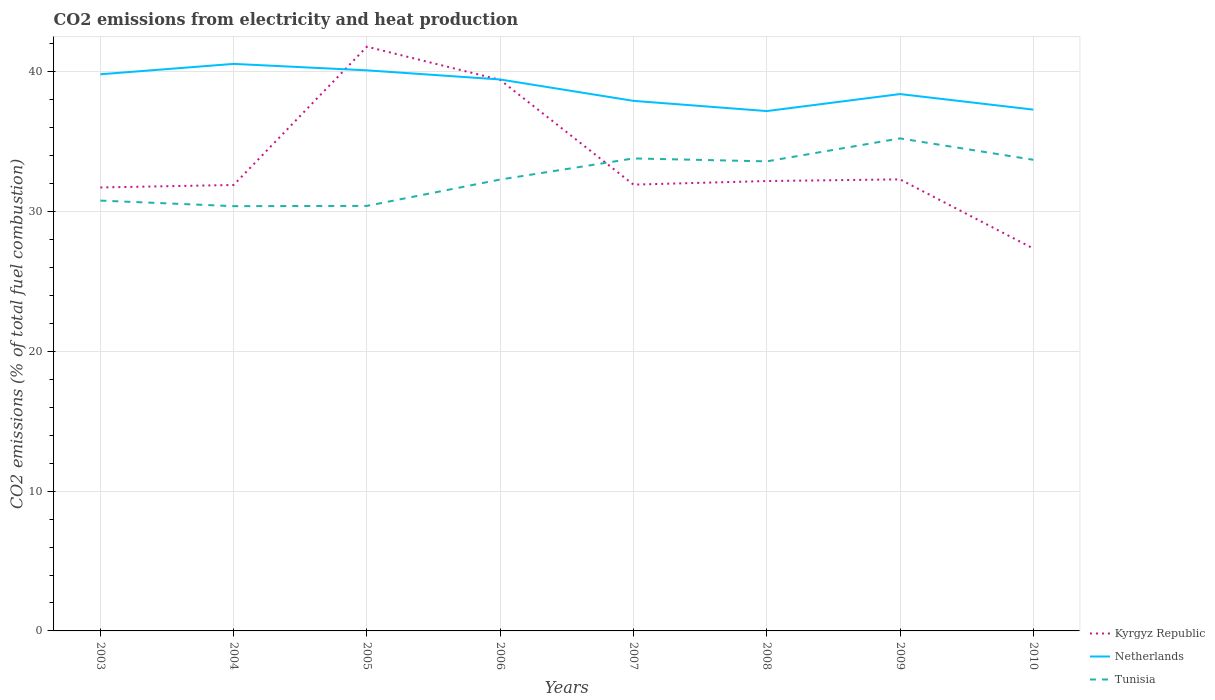Across all years, what is the maximum amount of CO2 emitted in Tunisia?
Your answer should be compact. 30.39. What is the total amount of CO2 emitted in Kyrgyz Republic in the graph?
Your answer should be compact. -0.46. What is the difference between the highest and the second highest amount of CO2 emitted in Netherlands?
Ensure brevity in your answer.  3.38. How many lines are there?
Your answer should be very brief. 3. How many years are there in the graph?
Ensure brevity in your answer.  8. What is the difference between two consecutive major ticks on the Y-axis?
Your answer should be compact. 10. Are the values on the major ticks of Y-axis written in scientific E-notation?
Provide a succinct answer. No. Does the graph contain any zero values?
Offer a terse response. No. Where does the legend appear in the graph?
Keep it short and to the point. Bottom right. How many legend labels are there?
Keep it short and to the point. 3. What is the title of the graph?
Provide a succinct answer. CO2 emissions from electricity and heat production. What is the label or title of the Y-axis?
Your answer should be compact. CO2 emissions (% of total fuel combustion). What is the CO2 emissions (% of total fuel combustion) in Kyrgyz Republic in 2003?
Make the answer very short. 31.73. What is the CO2 emissions (% of total fuel combustion) of Netherlands in 2003?
Provide a short and direct response. 39.83. What is the CO2 emissions (% of total fuel combustion) in Tunisia in 2003?
Provide a short and direct response. 30.79. What is the CO2 emissions (% of total fuel combustion) of Kyrgyz Republic in 2004?
Your response must be concise. 31.91. What is the CO2 emissions (% of total fuel combustion) in Netherlands in 2004?
Ensure brevity in your answer.  40.57. What is the CO2 emissions (% of total fuel combustion) in Tunisia in 2004?
Offer a very short reply. 30.39. What is the CO2 emissions (% of total fuel combustion) of Kyrgyz Republic in 2005?
Ensure brevity in your answer.  41.8. What is the CO2 emissions (% of total fuel combustion) of Netherlands in 2005?
Offer a terse response. 40.11. What is the CO2 emissions (% of total fuel combustion) of Tunisia in 2005?
Ensure brevity in your answer.  30.41. What is the CO2 emissions (% of total fuel combustion) in Kyrgyz Republic in 2006?
Offer a very short reply. 39.43. What is the CO2 emissions (% of total fuel combustion) of Netherlands in 2006?
Give a very brief answer. 39.45. What is the CO2 emissions (% of total fuel combustion) in Tunisia in 2006?
Provide a succinct answer. 32.3. What is the CO2 emissions (% of total fuel combustion) of Kyrgyz Republic in 2007?
Provide a short and direct response. 31.93. What is the CO2 emissions (% of total fuel combustion) in Netherlands in 2007?
Provide a short and direct response. 37.93. What is the CO2 emissions (% of total fuel combustion) of Tunisia in 2007?
Offer a terse response. 33.81. What is the CO2 emissions (% of total fuel combustion) in Kyrgyz Republic in 2008?
Provide a succinct answer. 32.19. What is the CO2 emissions (% of total fuel combustion) of Netherlands in 2008?
Ensure brevity in your answer.  37.2. What is the CO2 emissions (% of total fuel combustion) of Tunisia in 2008?
Provide a succinct answer. 33.6. What is the CO2 emissions (% of total fuel combustion) of Kyrgyz Republic in 2009?
Give a very brief answer. 32.31. What is the CO2 emissions (% of total fuel combustion) of Netherlands in 2009?
Your answer should be compact. 38.41. What is the CO2 emissions (% of total fuel combustion) in Tunisia in 2009?
Provide a succinct answer. 35.24. What is the CO2 emissions (% of total fuel combustion) in Kyrgyz Republic in 2010?
Your answer should be very brief. 27.36. What is the CO2 emissions (% of total fuel combustion) in Netherlands in 2010?
Your answer should be compact. 37.3. What is the CO2 emissions (% of total fuel combustion) of Tunisia in 2010?
Your answer should be compact. 33.71. Across all years, what is the maximum CO2 emissions (% of total fuel combustion) of Kyrgyz Republic?
Provide a succinct answer. 41.8. Across all years, what is the maximum CO2 emissions (% of total fuel combustion) of Netherlands?
Offer a terse response. 40.57. Across all years, what is the maximum CO2 emissions (% of total fuel combustion) in Tunisia?
Give a very brief answer. 35.24. Across all years, what is the minimum CO2 emissions (% of total fuel combustion) of Kyrgyz Republic?
Provide a short and direct response. 27.36. Across all years, what is the minimum CO2 emissions (% of total fuel combustion) in Netherlands?
Your response must be concise. 37.2. Across all years, what is the minimum CO2 emissions (% of total fuel combustion) of Tunisia?
Provide a short and direct response. 30.39. What is the total CO2 emissions (% of total fuel combustion) in Kyrgyz Republic in the graph?
Give a very brief answer. 268.66. What is the total CO2 emissions (% of total fuel combustion) in Netherlands in the graph?
Your answer should be compact. 310.79. What is the total CO2 emissions (% of total fuel combustion) in Tunisia in the graph?
Offer a terse response. 260.24. What is the difference between the CO2 emissions (% of total fuel combustion) in Kyrgyz Republic in 2003 and that in 2004?
Ensure brevity in your answer.  -0.18. What is the difference between the CO2 emissions (% of total fuel combustion) in Netherlands in 2003 and that in 2004?
Provide a succinct answer. -0.74. What is the difference between the CO2 emissions (% of total fuel combustion) in Tunisia in 2003 and that in 2004?
Keep it short and to the point. 0.4. What is the difference between the CO2 emissions (% of total fuel combustion) of Kyrgyz Republic in 2003 and that in 2005?
Provide a short and direct response. -10.07. What is the difference between the CO2 emissions (% of total fuel combustion) of Netherlands in 2003 and that in 2005?
Offer a very short reply. -0.28. What is the difference between the CO2 emissions (% of total fuel combustion) of Tunisia in 2003 and that in 2005?
Make the answer very short. 0.38. What is the difference between the CO2 emissions (% of total fuel combustion) of Kyrgyz Republic in 2003 and that in 2006?
Provide a short and direct response. -7.69. What is the difference between the CO2 emissions (% of total fuel combustion) of Netherlands in 2003 and that in 2006?
Provide a short and direct response. 0.37. What is the difference between the CO2 emissions (% of total fuel combustion) in Tunisia in 2003 and that in 2006?
Keep it short and to the point. -1.51. What is the difference between the CO2 emissions (% of total fuel combustion) in Kyrgyz Republic in 2003 and that in 2007?
Provide a succinct answer. -0.2. What is the difference between the CO2 emissions (% of total fuel combustion) in Netherlands in 2003 and that in 2007?
Your answer should be very brief. 1.9. What is the difference between the CO2 emissions (% of total fuel combustion) of Tunisia in 2003 and that in 2007?
Make the answer very short. -3.02. What is the difference between the CO2 emissions (% of total fuel combustion) of Kyrgyz Republic in 2003 and that in 2008?
Provide a succinct answer. -0.46. What is the difference between the CO2 emissions (% of total fuel combustion) of Netherlands in 2003 and that in 2008?
Your response must be concise. 2.63. What is the difference between the CO2 emissions (% of total fuel combustion) in Tunisia in 2003 and that in 2008?
Offer a terse response. -2.81. What is the difference between the CO2 emissions (% of total fuel combustion) of Kyrgyz Republic in 2003 and that in 2009?
Provide a succinct answer. -0.58. What is the difference between the CO2 emissions (% of total fuel combustion) of Netherlands in 2003 and that in 2009?
Provide a short and direct response. 1.42. What is the difference between the CO2 emissions (% of total fuel combustion) of Tunisia in 2003 and that in 2009?
Provide a succinct answer. -4.45. What is the difference between the CO2 emissions (% of total fuel combustion) in Kyrgyz Republic in 2003 and that in 2010?
Make the answer very short. 4.37. What is the difference between the CO2 emissions (% of total fuel combustion) of Netherlands in 2003 and that in 2010?
Provide a succinct answer. 2.53. What is the difference between the CO2 emissions (% of total fuel combustion) in Tunisia in 2003 and that in 2010?
Your answer should be very brief. -2.92. What is the difference between the CO2 emissions (% of total fuel combustion) of Kyrgyz Republic in 2004 and that in 2005?
Provide a short and direct response. -9.9. What is the difference between the CO2 emissions (% of total fuel combustion) of Netherlands in 2004 and that in 2005?
Your answer should be very brief. 0.46. What is the difference between the CO2 emissions (% of total fuel combustion) in Tunisia in 2004 and that in 2005?
Keep it short and to the point. -0.02. What is the difference between the CO2 emissions (% of total fuel combustion) in Kyrgyz Republic in 2004 and that in 2006?
Provide a succinct answer. -7.52. What is the difference between the CO2 emissions (% of total fuel combustion) in Netherlands in 2004 and that in 2006?
Provide a short and direct response. 1.12. What is the difference between the CO2 emissions (% of total fuel combustion) in Tunisia in 2004 and that in 2006?
Your response must be concise. -1.9. What is the difference between the CO2 emissions (% of total fuel combustion) of Kyrgyz Republic in 2004 and that in 2007?
Offer a very short reply. -0.03. What is the difference between the CO2 emissions (% of total fuel combustion) of Netherlands in 2004 and that in 2007?
Your answer should be very brief. 2.65. What is the difference between the CO2 emissions (% of total fuel combustion) of Tunisia in 2004 and that in 2007?
Ensure brevity in your answer.  -3.41. What is the difference between the CO2 emissions (% of total fuel combustion) in Kyrgyz Republic in 2004 and that in 2008?
Give a very brief answer. -0.28. What is the difference between the CO2 emissions (% of total fuel combustion) in Netherlands in 2004 and that in 2008?
Ensure brevity in your answer.  3.38. What is the difference between the CO2 emissions (% of total fuel combustion) in Tunisia in 2004 and that in 2008?
Provide a short and direct response. -3.2. What is the difference between the CO2 emissions (% of total fuel combustion) in Kyrgyz Republic in 2004 and that in 2009?
Your answer should be compact. -0.4. What is the difference between the CO2 emissions (% of total fuel combustion) in Netherlands in 2004 and that in 2009?
Ensure brevity in your answer.  2.16. What is the difference between the CO2 emissions (% of total fuel combustion) of Tunisia in 2004 and that in 2009?
Your answer should be very brief. -4.85. What is the difference between the CO2 emissions (% of total fuel combustion) in Kyrgyz Republic in 2004 and that in 2010?
Ensure brevity in your answer.  4.54. What is the difference between the CO2 emissions (% of total fuel combustion) in Netherlands in 2004 and that in 2010?
Give a very brief answer. 3.27. What is the difference between the CO2 emissions (% of total fuel combustion) in Tunisia in 2004 and that in 2010?
Make the answer very short. -3.32. What is the difference between the CO2 emissions (% of total fuel combustion) of Kyrgyz Republic in 2005 and that in 2006?
Offer a very short reply. 2.38. What is the difference between the CO2 emissions (% of total fuel combustion) in Netherlands in 2005 and that in 2006?
Give a very brief answer. 0.65. What is the difference between the CO2 emissions (% of total fuel combustion) of Tunisia in 2005 and that in 2006?
Your response must be concise. -1.88. What is the difference between the CO2 emissions (% of total fuel combustion) in Kyrgyz Republic in 2005 and that in 2007?
Give a very brief answer. 9.87. What is the difference between the CO2 emissions (% of total fuel combustion) in Netherlands in 2005 and that in 2007?
Ensure brevity in your answer.  2.18. What is the difference between the CO2 emissions (% of total fuel combustion) in Tunisia in 2005 and that in 2007?
Keep it short and to the point. -3.4. What is the difference between the CO2 emissions (% of total fuel combustion) in Kyrgyz Republic in 2005 and that in 2008?
Make the answer very short. 9.61. What is the difference between the CO2 emissions (% of total fuel combustion) of Netherlands in 2005 and that in 2008?
Give a very brief answer. 2.91. What is the difference between the CO2 emissions (% of total fuel combustion) in Tunisia in 2005 and that in 2008?
Keep it short and to the point. -3.19. What is the difference between the CO2 emissions (% of total fuel combustion) in Kyrgyz Republic in 2005 and that in 2009?
Your response must be concise. 9.5. What is the difference between the CO2 emissions (% of total fuel combustion) of Netherlands in 2005 and that in 2009?
Ensure brevity in your answer.  1.7. What is the difference between the CO2 emissions (% of total fuel combustion) of Tunisia in 2005 and that in 2009?
Provide a succinct answer. -4.83. What is the difference between the CO2 emissions (% of total fuel combustion) of Kyrgyz Republic in 2005 and that in 2010?
Your response must be concise. 14.44. What is the difference between the CO2 emissions (% of total fuel combustion) in Netherlands in 2005 and that in 2010?
Keep it short and to the point. 2.81. What is the difference between the CO2 emissions (% of total fuel combustion) in Tunisia in 2005 and that in 2010?
Ensure brevity in your answer.  -3.3. What is the difference between the CO2 emissions (% of total fuel combustion) in Kyrgyz Republic in 2006 and that in 2007?
Make the answer very short. 7.49. What is the difference between the CO2 emissions (% of total fuel combustion) of Netherlands in 2006 and that in 2007?
Provide a succinct answer. 1.53. What is the difference between the CO2 emissions (% of total fuel combustion) in Tunisia in 2006 and that in 2007?
Your response must be concise. -1.51. What is the difference between the CO2 emissions (% of total fuel combustion) of Kyrgyz Republic in 2006 and that in 2008?
Offer a very short reply. 7.24. What is the difference between the CO2 emissions (% of total fuel combustion) of Netherlands in 2006 and that in 2008?
Offer a very short reply. 2.26. What is the difference between the CO2 emissions (% of total fuel combustion) of Tunisia in 2006 and that in 2008?
Give a very brief answer. -1.3. What is the difference between the CO2 emissions (% of total fuel combustion) in Kyrgyz Republic in 2006 and that in 2009?
Make the answer very short. 7.12. What is the difference between the CO2 emissions (% of total fuel combustion) of Netherlands in 2006 and that in 2009?
Offer a terse response. 1.04. What is the difference between the CO2 emissions (% of total fuel combustion) of Tunisia in 2006 and that in 2009?
Make the answer very short. -2.94. What is the difference between the CO2 emissions (% of total fuel combustion) in Kyrgyz Republic in 2006 and that in 2010?
Provide a succinct answer. 12.06. What is the difference between the CO2 emissions (% of total fuel combustion) in Netherlands in 2006 and that in 2010?
Give a very brief answer. 2.16. What is the difference between the CO2 emissions (% of total fuel combustion) in Tunisia in 2006 and that in 2010?
Your answer should be very brief. -1.41. What is the difference between the CO2 emissions (% of total fuel combustion) in Kyrgyz Republic in 2007 and that in 2008?
Ensure brevity in your answer.  -0.26. What is the difference between the CO2 emissions (% of total fuel combustion) in Netherlands in 2007 and that in 2008?
Your response must be concise. 0.73. What is the difference between the CO2 emissions (% of total fuel combustion) of Tunisia in 2007 and that in 2008?
Give a very brief answer. 0.21. What is the difference between the CO2 emissions (% of total fuel combustion) in Kyrgyz Republic in 2007 and that in 2009?
Keep it short and to the point. -0.37. What is the difference between the CO2 emissions (% of total fuel combustion) in Netherlands in 2007 and that in 2009?
Provide a succinct answer. -0.49. What is the difference between the CO2 emissions (% of total fuel combustion) in Tunisia in 2007 and that in 2009?
Offer a very short reply. -1.43. What is the difference between the CO2 emissions (% of total fuel combustion) in Kyrgyz Republic in 2007 and that in 2010?
Give a very brief answer. 4.57. What is the difference between the CO2 emissions (% of total fuel combustion) in Netherlands in 2007 and that in 2010?
Ensure brevity in your answer.  0.63. What is the difference between the CO2 emissions (% of total fuel combustion) in Tunisia in 2007 and that in 2010?
Give a very brief answer. 0.1. What is the difference between the CO2 emissions (% of total fuel combustion) in Kyrgyz Republic in 2008 and that in 2009?
Keep it short and to the point. -0.12. What is the difference between the CO2 emissions (% of total fuel combustion) of Netherlands in 2008 and that in 2009?
Provide a short and direct response. -1.22. What is the difference between the CO2 emissions (% of total fuel combustion) of Tunisia in 2008 and that in 2009?
Offer a very short reply. -1.64. What is the difference between the CO2 emissions (% of total fuel combustion) of Kyrgyz Republic in 2008 and that in 2010?
Give a very brief answer. 4.83. What is the difference between the CO2 emissions (% of total fuel combustion) of Netherlands in 2008 and that in 2010?
Ensure brevity in your answer.  -0.1. What is the difference between the CO2 emissions (% of total fuel combustion) in Tunisia in 2008 and that in 2010?
Your answer should be compact. -0.11. What is the difference between the CO2 emissions (% of total fuel combustion) in Kyrgyz Republic in 2009 and that in 2010?
Provide a succinct answer. 4.94. What is the difference between the CO2 emissions (% of total fuel combustion) of Netherlands in 2009 and that in 2010?
Provide a short and direct response. 1.11. What is the difference between the CO2 emissions (% of total fuel combustion) in Tunisia in 2009 and that in 2010?
Keep it short and to the point. 1.53. What is the difference between the CO2 emissions (% of total fuel combustion) in Kyrgyz Republic in 2003 and the CO2 emissions (% of total fuel combustion) in Netherlands in 2004?
Provide a short and direct response. -8.84. What is the difference between the CO2 emissions (% of total fuel combustion) of Kyrgyz Republic in 2003 and the CO2 emissions (% of total fuel combustion) of Tunisia in 2004?
Make the answer very short. 1.34. What is the difference between the CO2 emissions (% of total fuel combustion) in Netherlands in 2003 and the CO2 emissions (% of total fuel combustion) in Tunisia in 2004?
Your response must be concise. 9.44. What is the difference between the CO2 emissions (% of total fuel combustion) in Kyrgyz Republic in 2003 and the CO2 emissions (% of total fuel combustion) in Netherlands in 2005?
Your answer should be very brief. -8.38. What is the difference between the CO2 emissions (% of total fuel combustion) in Kyrgyz Republic in 2003 and the CO2 emissions (% of total fuel combustion) in Tunisia in 2005?
Keep it short and to the point. 1.32. What is the difference between the CO2 emissions (% of total fuel combustion) of Netherlands in 2003 and the CO2 emissions (% of total fuel combustion) of Tunisia in 2005?
Ensure brevity in your answer.  9.42. What is the difference between the CO2 emissions (% of total fuel combustion) of Kyrgyz Republic in 2003 and the CO2 emissions (% of total fuel combustion) of Netherlands in 2006?
Give a very brief answer. -7.72. What is the difference between the CO2 emissions (% of total fuel combustion) in Kyrgyz Republic in 2003 and the CO2 emissions (% of total fuel combustion) in Tunisia in 2006?
Offer a terse response. -0.56. What is the difference between the CO2 emissions (% of total fuel combustion) of Netherlands in 2003 and the CO2 emissions (% of total fuel combustion) of Tunisia in 2006?
Offer a very short reply. 7.53. What is the difference between the CO2 emissions (% of total fuel combustion) in Kyrgyz Republic in 2003 and the CO2 emissions (% of total fuel combustion) in Netherlands in 2007?
Provide a short and direct response. -6.19. What is the difference between the CO2 emissions (% of total fuel combustion) of Kyrgyz Republic in 2003 and the CO2 emissions (% of total fuel combustion) of Tunisia in 2007?
Offer a terse response. -2.08. What is the difference between the CO2 emissions (% of total fuel combustion) of Netherlands in 2003 and the CO2 emissions (% of total fuel combustion) of Tunisia in 2007?
Your answer should be compact. 6.02. What is the difference between the CO2 emissions (% of total fuel combustion) of Kyrgyz Republic in 2003 and the CO2 emissions (% of total fuel combustion) of Netherlands in 2008?
Ensure brevity in your answer.  -5.46. What is the difference between the CO2 emissions (% of total fuel combustion) in Kyrgyz Republic in 2003 and the CO2 emissions (% of total fuel combustion) in Tunisia in 2008?
Provide a short and direct response. -1.87. What is the difference between the CO2 emissions (% of total fuel combustion) in Netherlands in 2003 and the CO2 emissions (% of total fuel combustion) in Tunisia in 2008?
Keep it short and to the point. 6.23. What is the difference between the CO2 emissions (% of total fuel combustion) of Kyrgyz Republic in 2003 and the CO2 emissions (% of total fuel combustion) of Netherlands in 2009?
Provide a short and direct response. -6.68. What is the difference between the CO2 emissions (% of total fuel combustion) of Kyrgyz Republic in 2003 and the CO2 emissions (% of total fuel combustion) of Tunisia in 2009?
Keep it short and to the point. -3.51. What is the difference between the CO2 emissions (% of total fuel combustion) in Netherlands in 2003 and the CO2 emissions (% of total fuel combustion) in Tunisia in 2009?
Make the answer very short. 4.59. What is the difference between the CO2 emissions (% of total fuel combustion) of Kyrgyz Republic in 2003 and the CO2 emissions (% of total fuel combustion) of Netherlands in 2010?
Your answer should be very brief. -5.57. What is the difference between the CO2 emissions (% of total fuel combustion) in Kyrgyz Republic in 2003 and the CO2 emissions (% of total fuel combustion) in Tunisia in 2010?
Make the answer very short. -1.98. What is the difference between the CO2 emissions (% of total fuel combustion) of Netherlands in 2003 and the CO2 emissions (% of total fuel combustion) of Tunisia in 2010?
Offer a terse response. 6.12. What is the difference between the CO2 emissions (% of total fuel combustion) in Kyrgyz Republic in 2004 and the CO2 emissions (% of total fuel combustion) in Netherlands in 2005?
Offer a terse response. -8.2. What is the difference between the CO2 emissions (% of total fuel combustion) in Kyrgyz Republic in 2004 and the CO2 emissions (% of total fuel combustion) in Tunisia in 2005?
Offer a terse response. 1.5. What is the difference between the CO2 emissions (% of total fuel combustion) in Netherlands in 2004 and the CO2 emissions (% of total fuel combustion) in Tunisia in 2005?
Your answer should be very brief. 10.16. What is the difference between the CO2 emissions (% of total fuel combustion) in Kyrgyz Republic in 2004 and the CO2 emissions (% of total fuel combustion) in Netherlands in 2006?
Provide a succinct answer. -7.55. What is the difference between the CO2 emissions (% of total fuel combustion) in Kyrgyz Republic in 2004 and the CO2 emissions (% of total fuel combustion) in Tunisia in 2006?
Offer a terse response. -0.39. What is the difference between the CO2 emissions (% of total fuel combustion) in Netherlands in 2004 and the CO2 emissions (% of total fuel combustion) in Tunisia in 2006?
Your response must be concise. 8.28. What is the difference between the CO2 emissions (% of total fuel combustion) in Kyrgyz Republic in 2004 and the CO2 emissions (% of total fuel combustion) in Netherlands in 2007?
Offer a very short reply. -6.02. What is the difference between the CO2 emissions (% of total fuel combustion) in Kyrgyz Republic in 2004 and the CO2 emissions (% of total fuel combustion) in Tunisia in 2007?
Give a very brief answer. -1.9. What is the difference between the CO2 emissions (% of total fuel combustion) in Netherlands in 2004 and the CO2 emissions (% of total fuel combustion) in Tunisia in 2007?
Provide a succinct answer. 6.76. What is the difference between the CO2 emissions (% of total fuel combustion) in Kyrgyz Republic in 2004 and the CO2 emissions (% of total fuel combustion) in Netherlands in 2008?
Your answer should be compact. -5.29. What is the difference between the CO2 emissions (% of total fuel combustion) in Kyrgyz Republic in 2004 and the CO2 emissions (% of total fuel combustion) in Tunisia in 2008?
Ensure brevity in your answer.  -1.69. What is the difference between the CO2 emissions (% of total fuel combustion) of Netherlands in 2004 and the CO2 emissions (% of total fuel combustion) of Tunisia in 2008?
Your answer should be very brief. 6.97. What is the difference between the CO2 emissions (% of total fuel combustion) in Kyrgyz Republic in 2004 and the CO2 emissions (% of total fuel combustion) in Netherlands in 2009?
Provide a short and direct response. -6.51. What is the difference between the CO2 emissions (% of total fuel combustion) of Kyrgyz Republic in 2004 and the CO2 emissions (% of total fuel combustion) of Tunisia in 2009?
Give a very brief answer. -3.33. What is the difference between the CO2 emissions (% of total fuel combustion) in Netherlands in 2004 and the CO2 emissions (% of total fuel combustion) in Tunisia in 2009?
Your answer should be very brief. 5.33. What is the difference between the CO2 emissions (% of total fuel combustion) in Kyrgyz Republic in 2004 and the CO2 emissions (% of total fuel combustion) in Netherlands in 2010?
Provide a short and direct response. -5.39. What is the difference between the CO2 emissions (% of total fuel combustion) of Kyrgyz Republic in 2004 and the CO2 emissions (% of total fuel combustion) of Tunisia in 2010?
Your answer should be compact. -1.8. What is the difference between the CO2 emissions (% of total fuel combustion) of Netherlands in 2004 and the CO2 emissions (% of total fuel combustion) of Tunisia in 2010?
Give a very brief answer. 6.86. What is the difference between the CO2 emissions (% of total fuel combustion) of Kyrgyz Republic in 2005 and the CO2 emissions (% of total fuel combustion) of Netherlands in 2006?
Make the answer very short. 2.35. What is the difference between the CO2 emissions (% of total fuel combustion) of Kyrgyz Republic in 2005 and the CO2 emissions (% of total fuel combustion) of Tunisia in 2006?
Your response must be concise. 9.51. What is the difference between the CO2 emissions (% of total fuel combustion) of Netherlands in 2005 and the CO2 emissions (% of total fuel combustion) of Tunisia in 2006?
Provide a short and direct response. 7.81. What is the difference between the CO2 emissions (% of total fuel combustion) in Kyrgyz Republic in 2005 and the CO2 emissions (% of total fuel combustion) in Netherlands in 2007?
Your response must be concise. 3.88. What is the difference between the CO2 emissions (% of total fuel combustion) of Kyrgyz Republic in 2005 and the CO2 emissions (% of total fuel combustion) of Tunisia in 2007?
Offer a terse response. 8. What is the difference between the CO2 emissions (% of total fuel combustion) of Netherlands in 2005 and the CO2 emissions (% of total fuel combustion) of Tunisia in 2007?
Your answer should be very brief. 6.3. What is the difference between the CO2 emissions (% of total fuel combustion) of Kyrgyz Republic in 2005 and the CO2 emissions (% of total fuel combustion) of Netherlands in 2008?
Provide a succinct answer. 4.61. What is the difference between the CO2 emissions (% of total fuel combustion) of Kyrgyz Republic in 2005 and the CO2 emissions (% of total fuel combustion) of Tunisia in 2008?
Give a very brief answer. 8.21. What is the difference between the CO2 emissions (% of total fuel combustion) in Netherlands in 2005 and the CO2 emissions (% of total fuel combustion) in Tunisia in 2008?
Your answer should be compact. 6.51. What is the difference between the CO2 emissions (% of total fuel combustion) in Kyrgyz Republic in 2005 and the CO2 emissions (% of total fuel combustion) in Netherlands in 2009?
Provide a short and direct response. 3.39. What is the difference between the CO2 emissions (% of total fuel combustion) of Kyrgyz Republic in 2005 and the CO2 emissions (% of total fuel combustion) of Tunisia in 2009?
Provide a succinct answer. 6.56. What is the difference between the CO2 emissions (% of total fuel combustion) of Netherlands in 2005 and the CO2 emissions (% of total fuel combustion) of Tunisia in 2009?
Your answer should be very brief. 4.87. What is the difference between the CO2 emissions (% of total fuel combustion) in Kyrgyz Republic in 2005 and the CO2 emissions (% of total fuel combustion) in Netherlands in 2010?
Offer a terse response. 4.5. What is the difference between the CO2 emissions (% of total fuel combustion) in Kyrgyz Republic in 2005 and the CO2 emissions (% of total fuel combustion) in Tunisia in 2010?
Your answer should be compact. 8.09. What is the difference between the CO2 emissions (% of total fuel combustion) of Netherlands in 2005 and the CO2 emissions (% of total fuel combustion) of Tunisia in 2010?
Offer a terse response. 6.4. What is the difference between the CO2 emissions (% of total fuel combustion) in Kyrgyz Republic in 2006 and the CO2 emissions (% of total fuel combustion) in Netherlands in 2007?
Your answer should be compact. 1.5. What is the difference between the CO2 emissions (% of total fuel combustion) in Kyrgyz Republic in 2006 and the CO2 emissions (% of total fuel combustion) in Tunisia in 2007?
Your response must be concise. 5.62. What is the difference between the CO2 emissions (% of total fuel combustion) in Netherlands in 2006 and the CO2 emissions (% of total fuel combustion) in Tunisia in 2007?
Offer a terse response. 5.65. What is the difference between the CO2 emissions (% of total fuel combustion) in Kyrgyz Republic in 2006 and the CO2 emissions (% of total fuel combustion) in Netherlands in 2008?
Offer a terse response. 2.23. What is the difference between the CO2 emissions (% of total fuel combustion) in Kyrgyz Republic in 2006 and the CO2 emissions (% of total fuel combustion) in Tunisia in 2008?
Your response must be concise. 5.83. What is the difference between the CO2 emissions (% of total fuel combustion) of Netherlands in 2006 and the CO2 emissions (% of total fuel combustion) of Tunisia in 2008?
Provide a succinct answer. 5.86. What is the difference between the CO2 emissions (% of total fuel combustion) in Kyrgyz Republic in 2006 and the CO2 emissions (% of total fuel combustion) in Netherlands in 2009?
Ensure brevity in your answer.  1.01. What is the difference between the CO2 emissions (% of total fuel combustion) in Kyrgyz Republic in 2006 and the CO2 emissions (% of total fuel combustion) in Tunisia in 2009?
Give a very brief answer. 4.19. What is the difference between the CO2 emissions (% of total fuel combustion) of Netherlands in 2006 and the CO2 emissions (% of total fuel combustion) of Tunisia in 2009?
Provide a short and direct response. 4.22. What is the difference between the CO2 emissions (% of total fuel combustion) in Kyrgyz Republic in 2006 and the CO2 emissions (% of total fuel combustion) in Netherlands in 2010?
Keep it short and to the point. 2.13. What is the difference between the CO2 emissions (% of total fuel combustion) of Kyrgyz Republic in 2006 and the CO2 emissions (% of total fuel combustion) of Tunisia in 2010?
Provide a short and direct response. 5.72. What is the difference between the CO2 emissions (% of total fuel combustion) in Netherlands in 2006 and the CO2 emissions (% of total fuel combustion) in Tunisia in 2010?
Offer a terse response. 5.75. What is the difference between the CO2 emissions (% of total fuel combustion) of Kyrgyz Republic in 2007 and the CO2 emissions (% of total fuel combustion) of Netherlands in 2008?
Your answer should be very brief. -5.26. What is the difference between the CO2 emissions (% of total fuel combustion) in Kyrgyz Republic in 2007 and the CO2 emissions (% of total fuel combustion) in Tunisia in 2008?
Ensure brevity in your answer.  -1.66. What is the difference between the CO2 emissions (% of total fuel combustion) in Netherlands in 2007 and the CO2 emissions (% of total fuel combustion) in Tunisia in 2008?
Keep it short and to the point. 4.33. What is the difference between the CO2 emissions (% of total fuel combustion) of Kyrgyz Republic in 2007 and the CO2 emissions (% of total fuel combustion) of Netherlands in 2009?
Your answer should be compact. -6.48. What is the difference between the CO2 emissions (% of total fuel combustion) in Kyrgyz Republic in 2007 and the CO2 emissions (% of total fuel combustion) in Tunisia in 2009?
Your answer should be very brief. -3.31. What is the difference between the CO2 emissions (% of total fuel combustion) in Netherlands in 2007 and the CO2 emissions (% of total fuel combustion) in Tunisia in 2009?
Offer a very short reply. 2.69. What is the difference between the CO2 emissions (% of total fuel combustion) in Kyrgyz Republic in 2007 and the CO2 emissions (% of total fuel combustion) in Netherlands in 2010?
Your response must be concise. -5.37. What is the difference between the CO2 emissions (% of total fuel combustion) of Kyrgyz Republic in 2007 and the CO2 emissions (% of total fuel combustion) of Tunisia in 2010?
Offer a very short reply. -1.78. What is the difference between the CO2 emissions (% of total fuel combustion) of Netherlands in 2007 and the CO2 emissions (% of total fuel combustion) of Tunisia in 2010?
Provide a short and direct response. 4.22. What is the difference between the CO2 emissions (% of total fuel combustion) of Kyrgyz Republic in 2008 and the CO2 emissions (% of total fuel combustion) of Netherlands in 2009?
Make the answer very short. -6.22. What is the difference between the CO2 emissions (% of total fuel combustion) in Kyrgyz Republic in 2008 and the CO2 emissions (% of total fuel combustion) in Tunisia in 2009?
Your answer should be very brief. -3.05. What is the difference between the CO2 emissions (% of total fuel combustion) in Netherlands in 2008 and the CO2 emissions (% of total fuel combustion) in Tunisia in 2009?
Give a very brief answer. 1.96. What is the difference between the CO2 emissions (% of total fuel combustion) of Kyrgyz Republic in 2008 and the CO2 emissions (% of total fuel combustion) of Netherlands in 2010?
Provide a succinct answer. -5.11. What is the difference between the CO2 emissions (% of total fuel combustion) of Kyrgyz Republic in 2008 and the CO2 emissions (% of total fuel combustion) of Tunisia in 2010?
Offer a very short reply. -1.52. What is the difference between the CO2 emissions (% of total fuel combustion) of Netherlands in 2008 and the CO2 emissions (% of total fuel combustion) of Tunisia in 2010?
Your response must be concise. 3.49. What is the difference between the CO2 emissions (% of total fuel combustion) of Kyrgyz Republic in 2009 and the CO2 emissions (% of total fuel combustion) of Netherlands in 2010?
Keep it short and to the point. -4.99. What is the difference between the CO2 emissions (% of total fuel combustion) of Kyrgyz Republic in 2009 and the CO2 emissions (% of total fuel combustion) of Tunisia in 2010?
Your response must be concise. -1.4. What is the difference between the CO2 emissions (% of total fuel combustion) in Netherlands in 2009 and the CO2 emissions (% of total fuel combustion) in Tunisia in 2010?
Provide a succinct answer. 4.7. What is the average CO2 emissions (% of total fuel combustion) in Kyrgyz Republic per year?
Offer a very short reply. 33.58. What is the average CO2 emissions (% of total fuel combustion) of Netherlands per year?
Keep it short and to the point. 38.85. What is the average CO2 emissions (% of total fuel combustion) of Tunisia per year?
Ensure brevity in your answer.  32.53. In the year 2003, what is the difference between the CO2 emissions (% of total fuel combustion) in Kyrgyz Republic and CO2 emissions (% of total fuel combustion) in Netherlands?
Give a very brief answer. -8.1. In the year 2003, what is the difference between the CO2 emissions (% of total fuel combustion) of Kyrgyz Republic and CO2 emissions (% of total fuel combustion) of Tunisia?
Your answer should be compact. 0.94. In the year 2003, what is the difference between the CO2 emissions (% of total fuel combustion) of Netherlands and CO2 emissions (% of total fuel combustion) of Tunisia?
Give a very brief answer. 9.04. In the year 2004, what is the difference between the CO2 emissions (% of total fuel combustion) in Kyrgyz Republic and CO2 emissions (% of total fuel combustion) in Netherlands?
Provide a short and direct response. -8.66. In the year 2004, what is the difference between the CO2 emissions (% of total fuel combustion) in Kyrgyz Republic and CO2 emissions (% of total fuel combustion) in Tunisia?
Offer a very short reply. 1.51. In the year 2004, what is the difference between the CO2 emissions (% of total fuel combustion) in Netherlands and CO2 emissions (% of total fuel combustion) in Tunisia?
Your answer should be compact. 10.18. In the year 2005, what is the difference between the CO2 emissions (% of total fuel combustion) in Kyrgyz Republic and CO2 emissions (% of total fuel combustion) in Netherlands?
Your response must be concise. 1.69. In the year 2005, what is the difference between the CO2 emissions (% of total fuel combustion) of Kyrgyz Republic and CO2 emissions (% of total fuel combustion) of Tunisia?
Provide a succinct answer. 11.39. In the year 2005, what is the difference between the CO2 emissions (% of total fuel combustion) of Netherlands and CO2 emissions (% of total fuel combustion) of Tunisia?
Your answer should be very brief. 9.7. In the year 2006, what is the difference between the CO2 emissions (% of total fuel combustion) in Kyrgyz Republic and CO2 emissions (% of total fuel combustion) in Netherlands?
Provide a succinct answer. -0.03. In the year 2006, what is the difference between the CO2 emissions (% of total fuel combustion) of Kyrgyz Republic and CO2 emissions (% of total fuel combustion) of Tunisia?
Provide a short and direct response. 7.13. In the year 2006, what is the difference between the CO2 emissions (% of total fuel combustion) of Netherlands and CO2 emissions (% of total fuel combustion) of Tunisia?
Give a very brief answer. 7.16. In the year 2007, what is the difference between the CO2 emissions (% of total fuel combustion) in Kyrgyz Republic and CO2 emissions (% of total fuel combustion) in Netherlands?
Give a very brief answer. -5.99. In the year 2007, what is the difference between the CO2 emissions (% of total fuel combustion) of Kyrgyz Republic and CO2 emissions (% of total fuel combustion) of Tunisia?
Ensure brevity in your answer.  -1.87. In the year 2007, what is the difference between the CO2 emissions (% of total fuel combustion) in Netherlands and CO2 emissions (% of total fuel combustion) in Tunisia?
Give a very brief answer. 4.12. In the year 2008, what is the difference between the CO2 emissions (% of total fuel combustion) of Kyrgyz Republic and CO2 emissions (% of total fuel combustion) of Netherlands?
Provide a short and direct response. -5.01. In the year 2008, what is the difference between the CO2 emissions (% of total fuel combustion) in Kyrgyz Republic and CO2 emissions (% of total fuel combustion) in Tunisia?
Give a very brief answer. -1.41. In the year 2008, what is the difference between the CO2 emissions (% of total fuel combustion) of Netherlands and CO2 emissions (% of total fuel combustion) of Tunisia?
Your response must be concise. 3.6. In the year 2009, what is the difference between the CO2 emissions (% of total fuel combustion) in Kyrgyz Republic and CO2 emissions (% of total fuel combustion) in Netherlands?
Offer a very short reply. -6.1. In the year 2009, what is the difference between the CO2 emissions (% of total fuel combustion) of Kyrgyz Republic and CO2 emissions (% of total fuel combustion) of Tunisia?
Offer a very short reply. -2.93. In the year 2009, what is the difference between the CO2 emissions (% of total fuel combustion) of Netherlands and CO2 emissions (% of total fuel combustion) of Tunisia?
Give a very brief answer. 3.17. In the year 2010, what is the difference between the CO2 emissions (% of total fuel combustion) of Kyrgyz Republic and CO2 emissions (% of total fuel combustion) of Netherlands?
Give a very brief answer. -9.94. In the year 2010, what is the difference between the CO2 emissions (% of total fuel combustion) in Kyrgyz Republic and CO2 emissions (% of total fuel combustion) in Tunisia?
Provide a succinct answer. -6.35. In the year 2010, what is the difference between the CO2 emissions (% of total fuel combustion) in Netherlands and CO2 emissions (% of total fuel combustion) in Tunisia?
Provide a succinct answer. 3.59. What is the ratio of the CO2 emissions (% of total fuel combustion) in Netherlands in 2003 to that in 2004?
Ensure brevity in your answer.  0.98. What is the ratio of the CO2 emissions (% of total fuel combustion) in Tunisia in 2003 to that in 2004?
Keep it short and to the point. 1.01. What is the ratio of the CO2 emissions (% of total fuel combustion) in Kyrgyz Republic in 2003 to that in 2005?
Provide a short and direct response. 0.76. What is the ratio of the CO2 emissions (% of total fuel combustion) of Netherlands in 2003 to that in 2005?
Your answer should be compact. 0.99. What is the ratio of the CO2 emissions (% of total fuel combustion) in Tunisia in 2003 to that in 2005?
Ensure brevity in your answer.  1.01. What is the ratio of the CO2 emissions (% of total fuel combustion) in Kyrgyz Republic in 2003 to that in 2006?
Keep it short and to the point. 0.8. What is the ratio of the CO2 emissions (% of total fuel combustion) in Netherlands in 2003 to that in 2006?
Give a very brief answer. 1.01. What is the ratio of the CO2 emissions (% of total fuel combustion) in Tunisia in 2003 to that in 2006?
Offer a very short reply. 0.95. What is the ratio of the CO2 emissions (% of total fuel combustion) in Kyrgyz Republic in 2003 to that in 2007?
Your answer should be compact. 0.99. What is the ratio of the CO2 emissions (% of total fuel combustion) of Netherlands in 2003 to that in 2007?
Offer a terse response. 1.05. What is the ratio of the CO2 emissions (% of total fuel combustion) in Tunisia in 2003 to that in 2007?
Offer a very short reply. 0.91. What is the ratio of the CO2 emissions (% of total fuel combustion) in Kyrgyz Republic in 2003 to that in 2008?
Offer a very short reply. 0.99. What is the ratio of the CO2 emissions (% of total fuel combustion) of Netherlands in 2003 to that in 2008?
Your answer should be compact. 1.07. What is the ratio of the CO2 emissions (% of total fuel combustion) of Tunisia in 2003 to that in 2008?
Your answer should be compact. 0.92. What is the ratio of the CO2 emissions (% of total fuel combustion) in Kyrgyz Republic in 2003 to that in 2009?
Your response must be concise. 0.98. What is the ratio of the CO2 emissions (% of total fuel combustion) of Netherlands in 2003 to that in 2009?
Keep it short and to the point. 1.04. What is the ratio of the CO2 emissions (% of total fuel combustion) in Tunisia in 2003 to that in 2009?
Offer a very short reply. 0.87. What is the ratio of the CO2 emissions (% of total fuel combustion) in Kyrgyz Republic in 2003 to that in 2010?
Your answer should be very brief. 1.16. What is the ratio of the CO2 emissions (% of total fuel combustion) of Netherlands in 2003 to that in 2010?
Make the answer very short. 1.07. What is the ratio of the CO2 emissions (% of total fuel combustion) of Tunisia in 2003 to that in 2010?
Your answer should be very brief. 0.91. What is the ratio of the CO2 emissions (% of total fuel combustion) of Kyrgyz Republic in 2004 to that in 2005?
Provide a short and direct response. 0.76. What is the ratio of the CO2 emissions (% of total fuel combustion) of Netherlands in 2004 to that in 2005?
Your answer should be very brief. 1.01. What is the ratio of the CO2 emissions (% of total fuel combustion) in Kyrgyz Republic in 2004 to that in 2006?
Offer a terse response. 0.81. What is the ratio of the CO2 emissions (% of total fuel combustion) of Netherlands in 2004 to that in 2006?
Make the answer very short. 1.03. What is the ratio of the CO2 emissions (% of total fuel combustion) of Tunisia in 2004 to that in 2006?
Provide a short and direct response. 0.94. What is the ratio of the CO2 emissions (% of total fuel combustion) in Netherlands in 2004 to that in 2007?
Offer a terse response. 1.07. What is the ratio of the CO2 emissions (% of total fuel combustion) in Tunisia in 2004 to that in 2007?
Provide a short and direct response. 0.9. What is the ratio of the CO2 emissions (% of total fuel combustion) in Netherlands in 2004 to that in 2008?
Provide a short and direct response. 1.09. What is the ratio of the CO2 emissions (% of total fuel combustion) of Tunisia in 2004 to that in 2008?
Keep it short and to the point. 0.9. What is the ratio of the CO2 emissions (% of total fuel combustion) in Kyrgyz Republic in 2004 to that in 2009?
Offer a very short reply. 0.99. What is the ratio of the CO2 emissions (% of total fuel combustion) in Netherlands in 2004 to that in 2009?
Offer a terse response. 1.06. What is the ratio of the CO2 emissions (% of total fuel combustion) in Tunisia in 2004 to that in 2009?
Your response must be concise. 0.86. What is the ratio of the CO2 emissions (% of total fuel combustion) of Kyrgyz Republic in 2004 to that in 2010?
Give a very brief answer. 1.17. What is the ratio of the CO2 emissions (% of total fuel combustion) of Netherlands in 2004 to that in 2010?
Your answer should be very brief. 1.09. What is the ratio of the CO2 emissions (% of total fuel combustion) of Tunisia in 2004 to that in 2010?
Your answer should be very brief. 0.9. What is the ratio of the CO2 emissions (% of total fuel combustion) of Kyrgyz Republic in 2005 to that in 2006?
Give a very brief answer. 1.06. What is the ratio of the CO2 emissions (% of total fuel combustion) of Netherlands in 2005 to that in 2006?
Your answer should be very brief. 1.02. What is the ratio of the CO2 emissions (% of total fuel combustion) in Tunisia in 2005 to that in 2006?
Keep it short and to the point. 0.94. What is the ratio of the CO2 emissions (% of total fuel combustion) of Kyrgyz Republic in 2005 to that in 2007?
Make the answer very short. 1.31. What is the ratio of the CO2 emissions (% of total fuel combustion) in Netherlands in 2005 to that in 2007?
Your response must be concise. 1.06. What is the ratio of the CO2 emissions (% of total fuel combustion) in Tunisia in 2005 to that in 2007?
Your answer should be very brief. 0.9. What is the ratio of the CO2 emissions (% of total fuel combustion) of Kyrgyz Republic in 2005 to that in 2008?
Make the answer very short. 1.3. What is the ratio of the CO2 emissions (% of total fuel combustion) in Netherlands in 2005 to that in 2008?
Offer a terse response. 1.08. What is the ratio of the CO2 emissions (% of total fuel combustion) in Tunisia in 2005 to that in 2008?
Offer a terse response. 0.91. What is the ratio of the CO2 emissions (% of total fuel combustion) of Kyrgyz Republic in 2005 to that in 2009?
Offer a terse response. 1.29. What is the ratio of the CO2 emissions (% of total fuel combustion) in Netherlands in 2005 to that in 2009?
Make the answer very short. 1.04. What is the ratio of the CO2 emissions (% of total fuel combustion) in Tunisia in 2005 to that in 2009?
Offer a very short reply. 0.86. What is the ratio of the CO2 emissions (% of total fuel combustion) in Kyrgyz Republic in 2005 to that in 2010?
Make the answer very short. 1.53. What is the ratio of the CO2 emissions (% of total fuel combustion) of Netherlands in 2005 to that in 2010?
Your answer should be very brief. 1.08. What is the ratio of the CO2 emissions (% of total fuel combustion) of Tunisia in 2005 to that in 2010?
Ensure brevity in your answer.  0.9. What is the ratio of the CO2 emissions (% of total fuel combustion) in Kyrgyz Republic in 2006 to that in 2007?
Keep it short and to the point. 1.23. What is the ratio of the CO2 emissions (% of total fuel combustion) in Netherlands in 2006 to that in 2007?
Your answer should be compact. 1.04. What is the ratio of the CO2 emissions (% of total fuel combustion) of Tunisia in 2006 to that in 2007?
Offer a very short reply. 0.96. What is the ratio of the CO2 emissions (% of total fuel combustion) in Kyrgyz Republic in 2006 to that in 2008?
Your response must be concise. 1.22. What is the ratio of the CO2 emissions (% of total fuel combustion) of Netherlands in 2006 to that in 2008?
Keep it short and to the point. 1.06. What is the ratio of the CO2 emissions (% of total fuel combustion) of Tunisia in 2006 to that in 2008?
Ensure brevity in your answer.  0.96. What is the ratio of the CO2 emissions (% of total fuel combustion) of Kyrgyz Republic in 2006 to that in 2009?
Your answer should be compact. 1.22. What is the ratio of the CO2 emissions (% of total fuel combustion) in Netherlands in 2006 to that in 2009?
Provide a short and direct response. 1.03. What is the ratio of the CO2 emissions (% of total fuel combustion) of Tunisia in 2006 to that in 2009?
Keep it short and to the point. 0.92. What is the ratio of the CO2 emissions (% of total fuel combustion) of Kyrgyz Republic in 2006 to that in 2010?
Provide a short and direct response. 1.44. What is the ratio of the CO2 emissions (% of total fuel combustion) in Netherlands in 2006 to that in 2010?
Keep it short and to the point. 1.06. What is the ratio of the CO2 emissions (% of total fuel combustion) in Tunisia in 2006 to that in 2010?
Provide a succinct answer. 0.96. What is the ratio of the CO2 emissions (% of total fuel combustion) in Kyrgyz Republic in 2007 to that in 2008?
Your answer should be very brief. 0.99. What is the ratio of the CO2 emissions (% of total fuel combustion) of Netherlands in 2007 to that in 2008?
Offer a terse response. 1.02. What is the ratio of the CO2 emissions (% of total fuel combustion) of Tunisia in 2007 to that in 2008?
Provide a short and direct response. 1.01. What is the ratio of the CO2 emissions (% of total fuel combustion) in Kyrgyz Republic in 2007 to that in 2009?
Provide a short and direct response. 0.99. What is the ratio of the CO2 emissions (% of total fuel combustion) of Netherlands in 2007 to that in 2009?
Offer a very short reply. 0.99. What is the ratio of the CO2 emissions (% of total fuel combustion) of Tunisia in 2007 to that in 2009?
Provide a short and direct response. 0.96. What is the ratio of the CO2 emissions (% of total fuel combustion) of Kyrgyz Republic in 2007 to that in 2010?
Offer a very short reply. 1.17. What is the ratio of the CO2 emissions (% of total fuel combustion) of Netherlands in 2007 to that in 2010?
Offer a terse response. 1.02. What is the ratio of the CO2 emissions (% of total fuel combustion) of Kyrgyz Republic in 2008 to that in 2009?
Your answer should be compact. 1. What is the ratio of the CO2 emissions (% of total fuel combustion) in Netherlands in 2008 to that in 2009?
Make the answer very short. 0.97. What is the ratio of the CO2 emissions (% of total fuel combustion) of Tunisia in 2008 to that in 2009?
Make the answer very short. 0.95. What is the ratio of the CO2 emissions (% of total fuel combustion) in Kyrgyz Republic in 2008 to that in 2010?
Give a very brief answer. 1.18. What is the ratio of the CO2 emissions (% of total fuel combustion) in Netherlands in 2008 to that in 2010?
Provide a short and direct response. 1. What is the ratio of the CO2 emissions (% of total fuel combustion) of Tunisia in 2008 to that in 2010?
Your response must be concise. 1. What is the ratio of the CO2 emissions (% of total fuel combustion) of Kyrgyz Republic in 2009 to that in 2010?
Provide a short and direct response. 1.18. What is the ratio of the CO2 emissions (% of total fuel combustion) in Netherlands in 2009 to that in 2010?
Ensure brevity in your answer.  1.03. What is the ratio of the CO2 emissions (% of total fuel combustion) of Tunisia in 2009 to that in 2010?
Offer a very short reply. 1.05. What is the difference between the highest and the second highest CO2 emissions (% of total fuel combustion) of Kyrgyz Republic?
Make the answer very short. 2.38. What is the difference between the highest and the second highest CO2 emissions (% of total fuel combustion) in Netherlands?
Offer a terse response. 0.46. What is the difference between the highest and the second highest CO2 emissions (% of total fuel combustion) of Tunisia?
Offer a very short reply. 1.43. What is the difference between the highest and the lowest CO2 emissions (% of total fuel combustion) of Kyrgyz Republic?
Offer a very short reply. 14.44. What is the difference between the highest and the lowest CO2 emissions (% of total fuel combustion) of Netherlands?
Offer a terse response. 3.38. What is the difference between the highest and the lowest CO2 emissions (% of total fuel combustion) in Tunisia?
Ensure brevity in your answer.  4.85. 